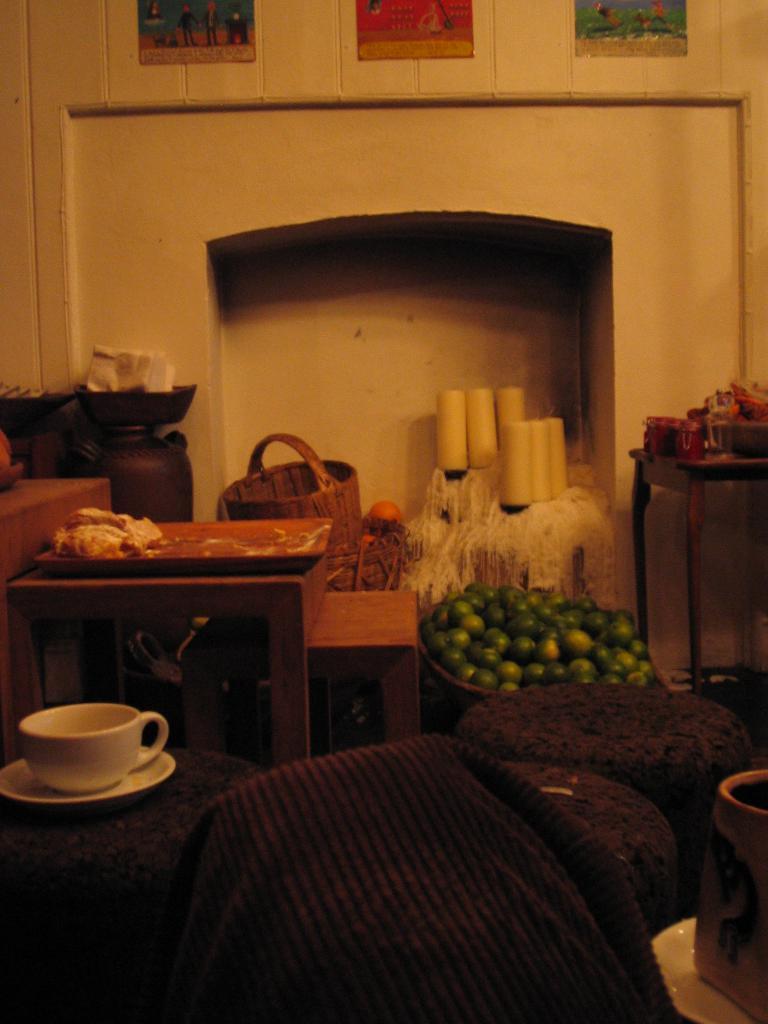Could you give a brief overview of what you see in this image? This picture is consists of a room, where there are three posters above the area of the image on the wall, there are some vegetables on the floor, there is a desk at the left side of the image, there is a cup and saucer, which is placed on sofa, there is a table at the right side of the image which contains basket on it. 